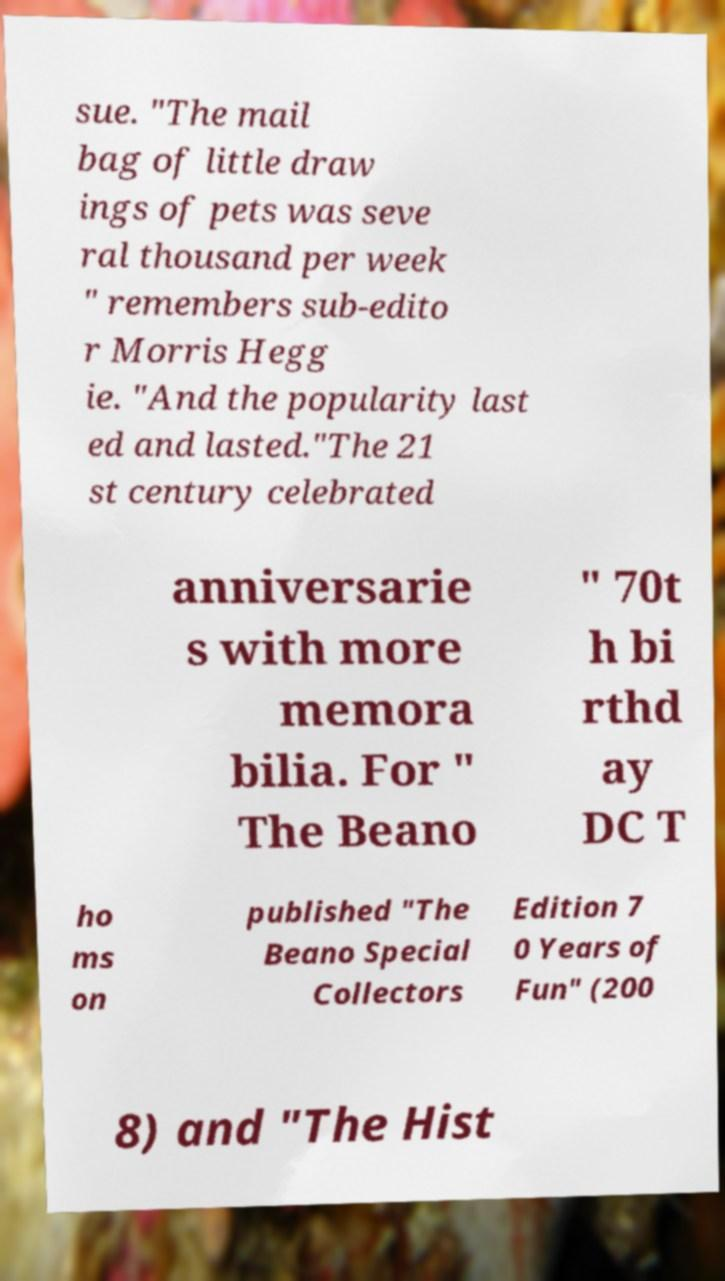For documentation purposes, I need the text within this image transcribed. Could you provide that? sue. "The mail bag of little draw ings of pets was seve ral thousand per week " remembers sub-edito r Morris Hegg ie. "And the popularity last ed and lasted."The 21 st century celebrated anniversarie s with more memora bilia. For " The Beano " 70t h bi rthd ay DC T ho ms on published "The Beano Special Collectors Edition 7 0 Years of Fun" (200 8) and "The Hist 